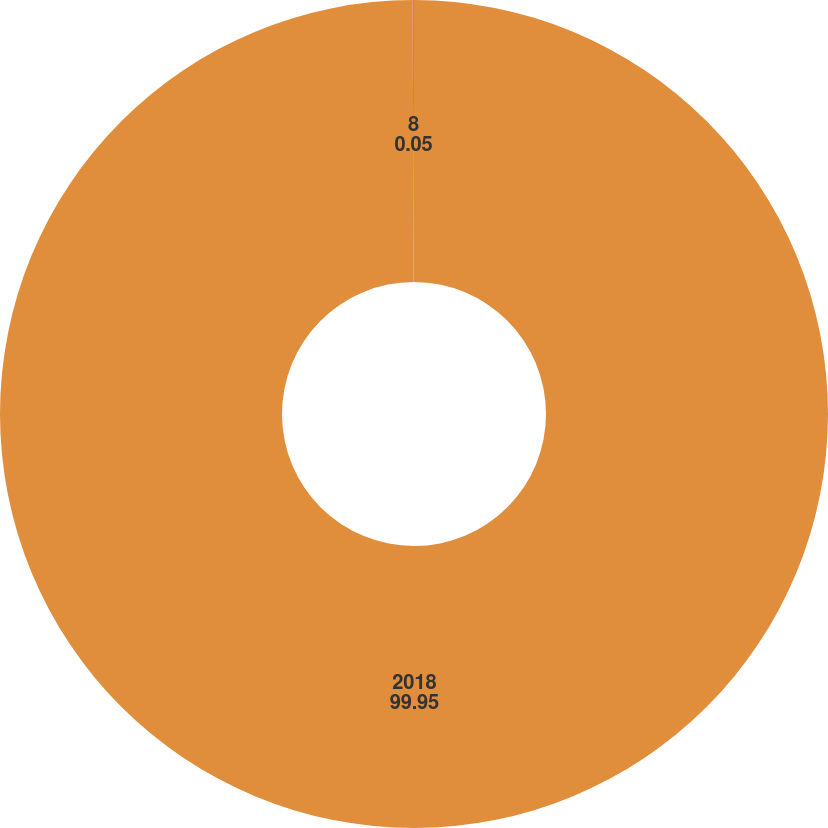Convert chart to OTSL. <chart><loc_0><loc_0><loc_500><loc_500><pie_chart><fcel>2018<fcel>8<nl><fcel>99.95%<fcel>0.05%<nl></chart> 